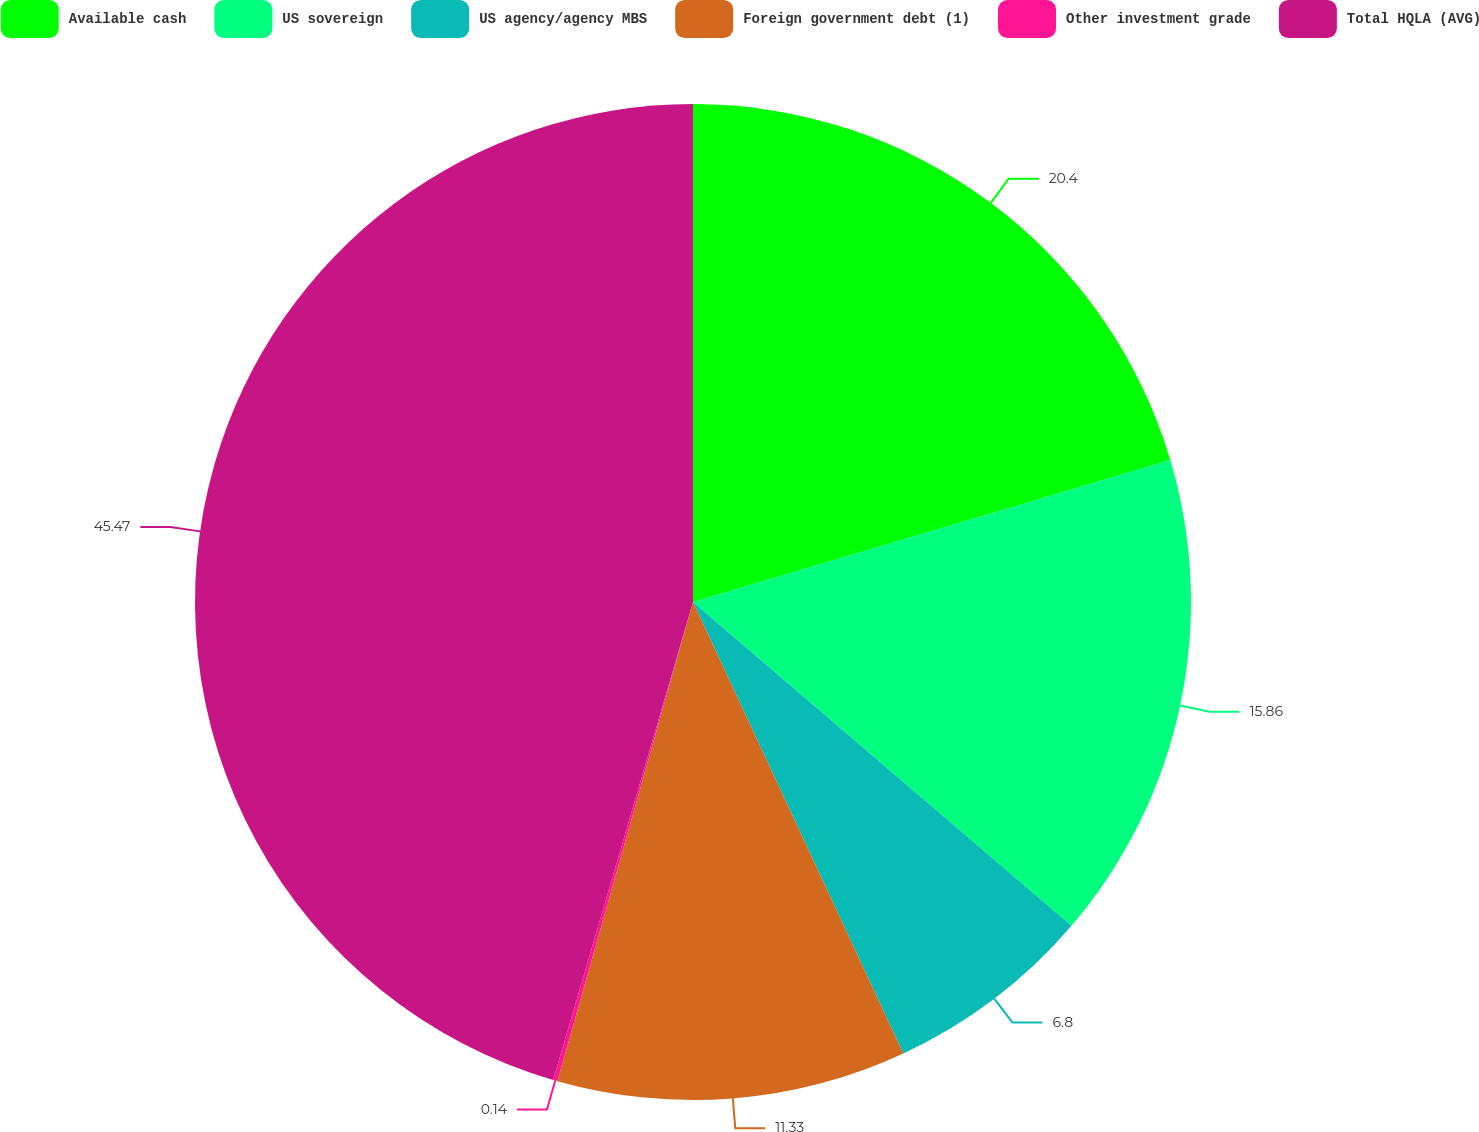Convert chart. <chart><loc_0><loc_0><loc_500><loc_500><pie_chart><fcel>Available cash<fcel>US sovereign<fcel>US agency/agency MBS<fcel>Foreign government debt (1)<fcel>Other investment grade<fcel>Total HQLA (AVG)<nl><fcel>20.4%<fcel>15.86%<fcel>6.8%<fcel>11.33%<fcel>0.14%<fcel>45.47%<nl></chart> 